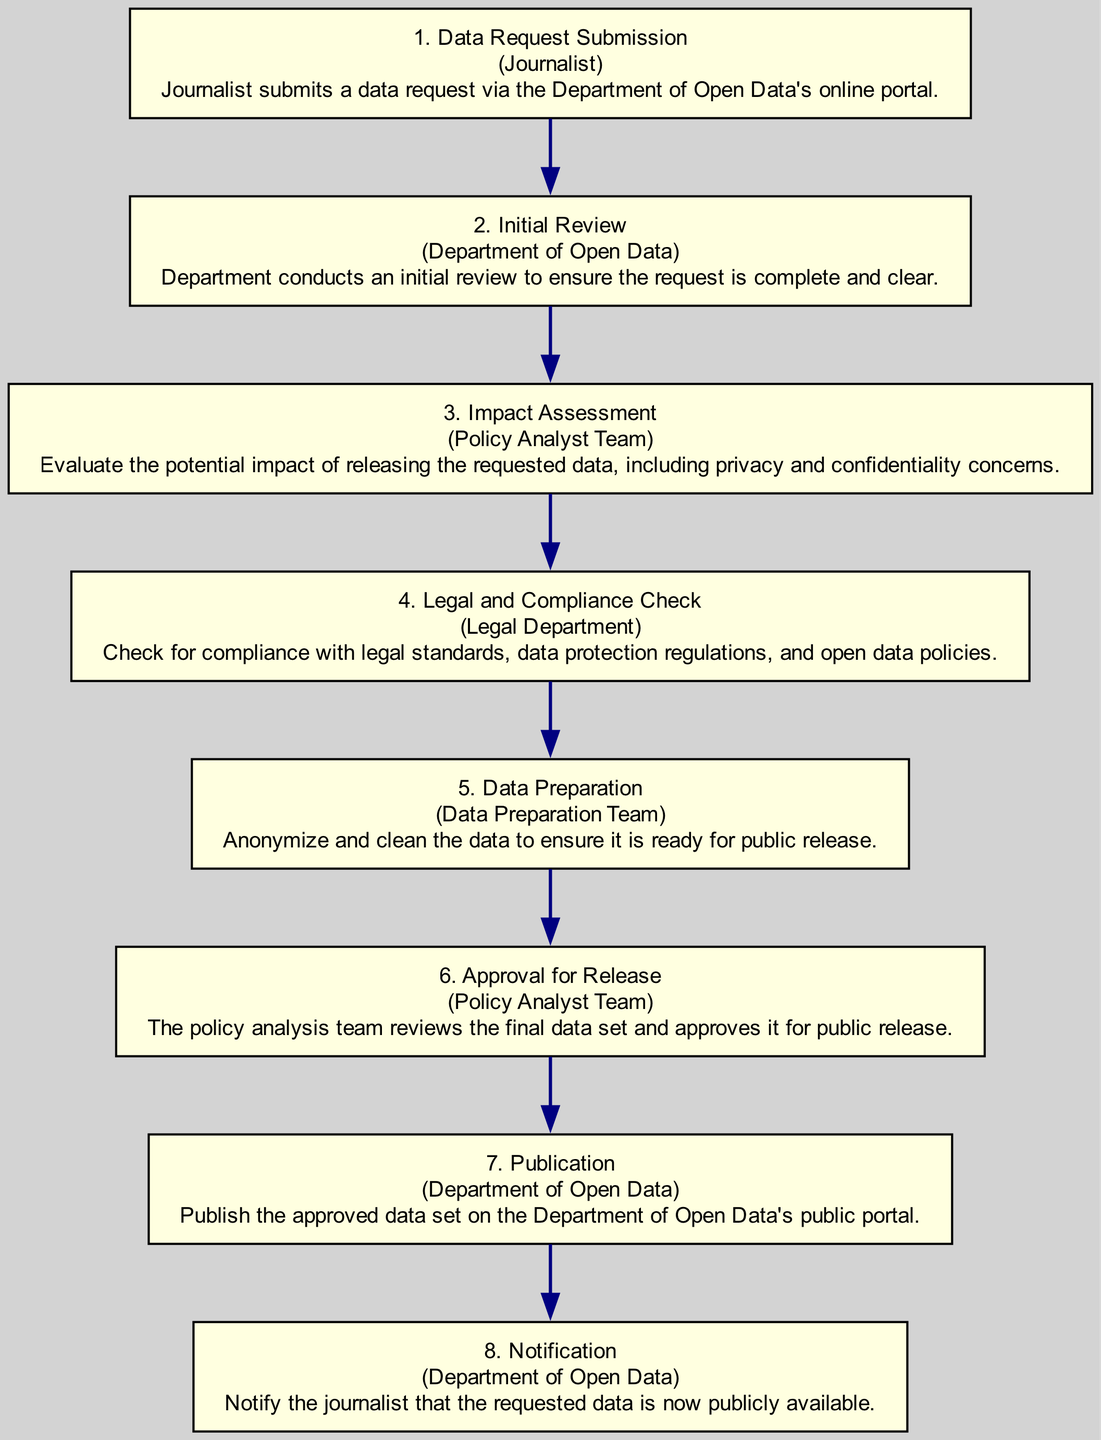What is the first step in the workflow? The first step is labeled "1. Data Request Submission" which indicates the initial action in the process.
Answer: Data Request Submission Which entity is responsible for the initial review? The initial review is conducted by the "Department of Open Data," as indicated in the second step.
Answer: Department of Open Data How many steps are in the workflow? The diagram consists of eight steps in total, indicating a comprehensive process for data release.
Answer: 8 What follows the legal and compliance check? The step that follows "4. Legal and Compliance Check" is "5. Data Preparation," which is the next action in the sequence.
Answer: Data Preparation Which step involves anonymizing and cleaning data? "5. Data Preparation" specifically mentions the process of anonymizing and cleaning the data to ensure it's ready for public release.
Answer: Data Preparation What is the last action in the workflow? The final action in the workflow is "8. Notification," where the department notifies the journalist about data availability.
Answer: Notification What are the two teams involved in the workflow? The two teams mentioned in the workflow are the "Policy Analyst Team" and the "Data Preparation Team," responsible for different aspects of the process.
Answer: Policy Analyst Team, Data Preparation Team What is assessed during the impact assessment? The impact assessment evaluates the potential impact of releasing the data, including concerns related to privacy and confidentiality.
Answer: Privacy and confidentiality concerns Which step occurs after the data preparation? After "5. Data Preparation," the next step is "6. Approval for Release," outlining the approval process for the finalized dataset.
Answer: Approval for Release 